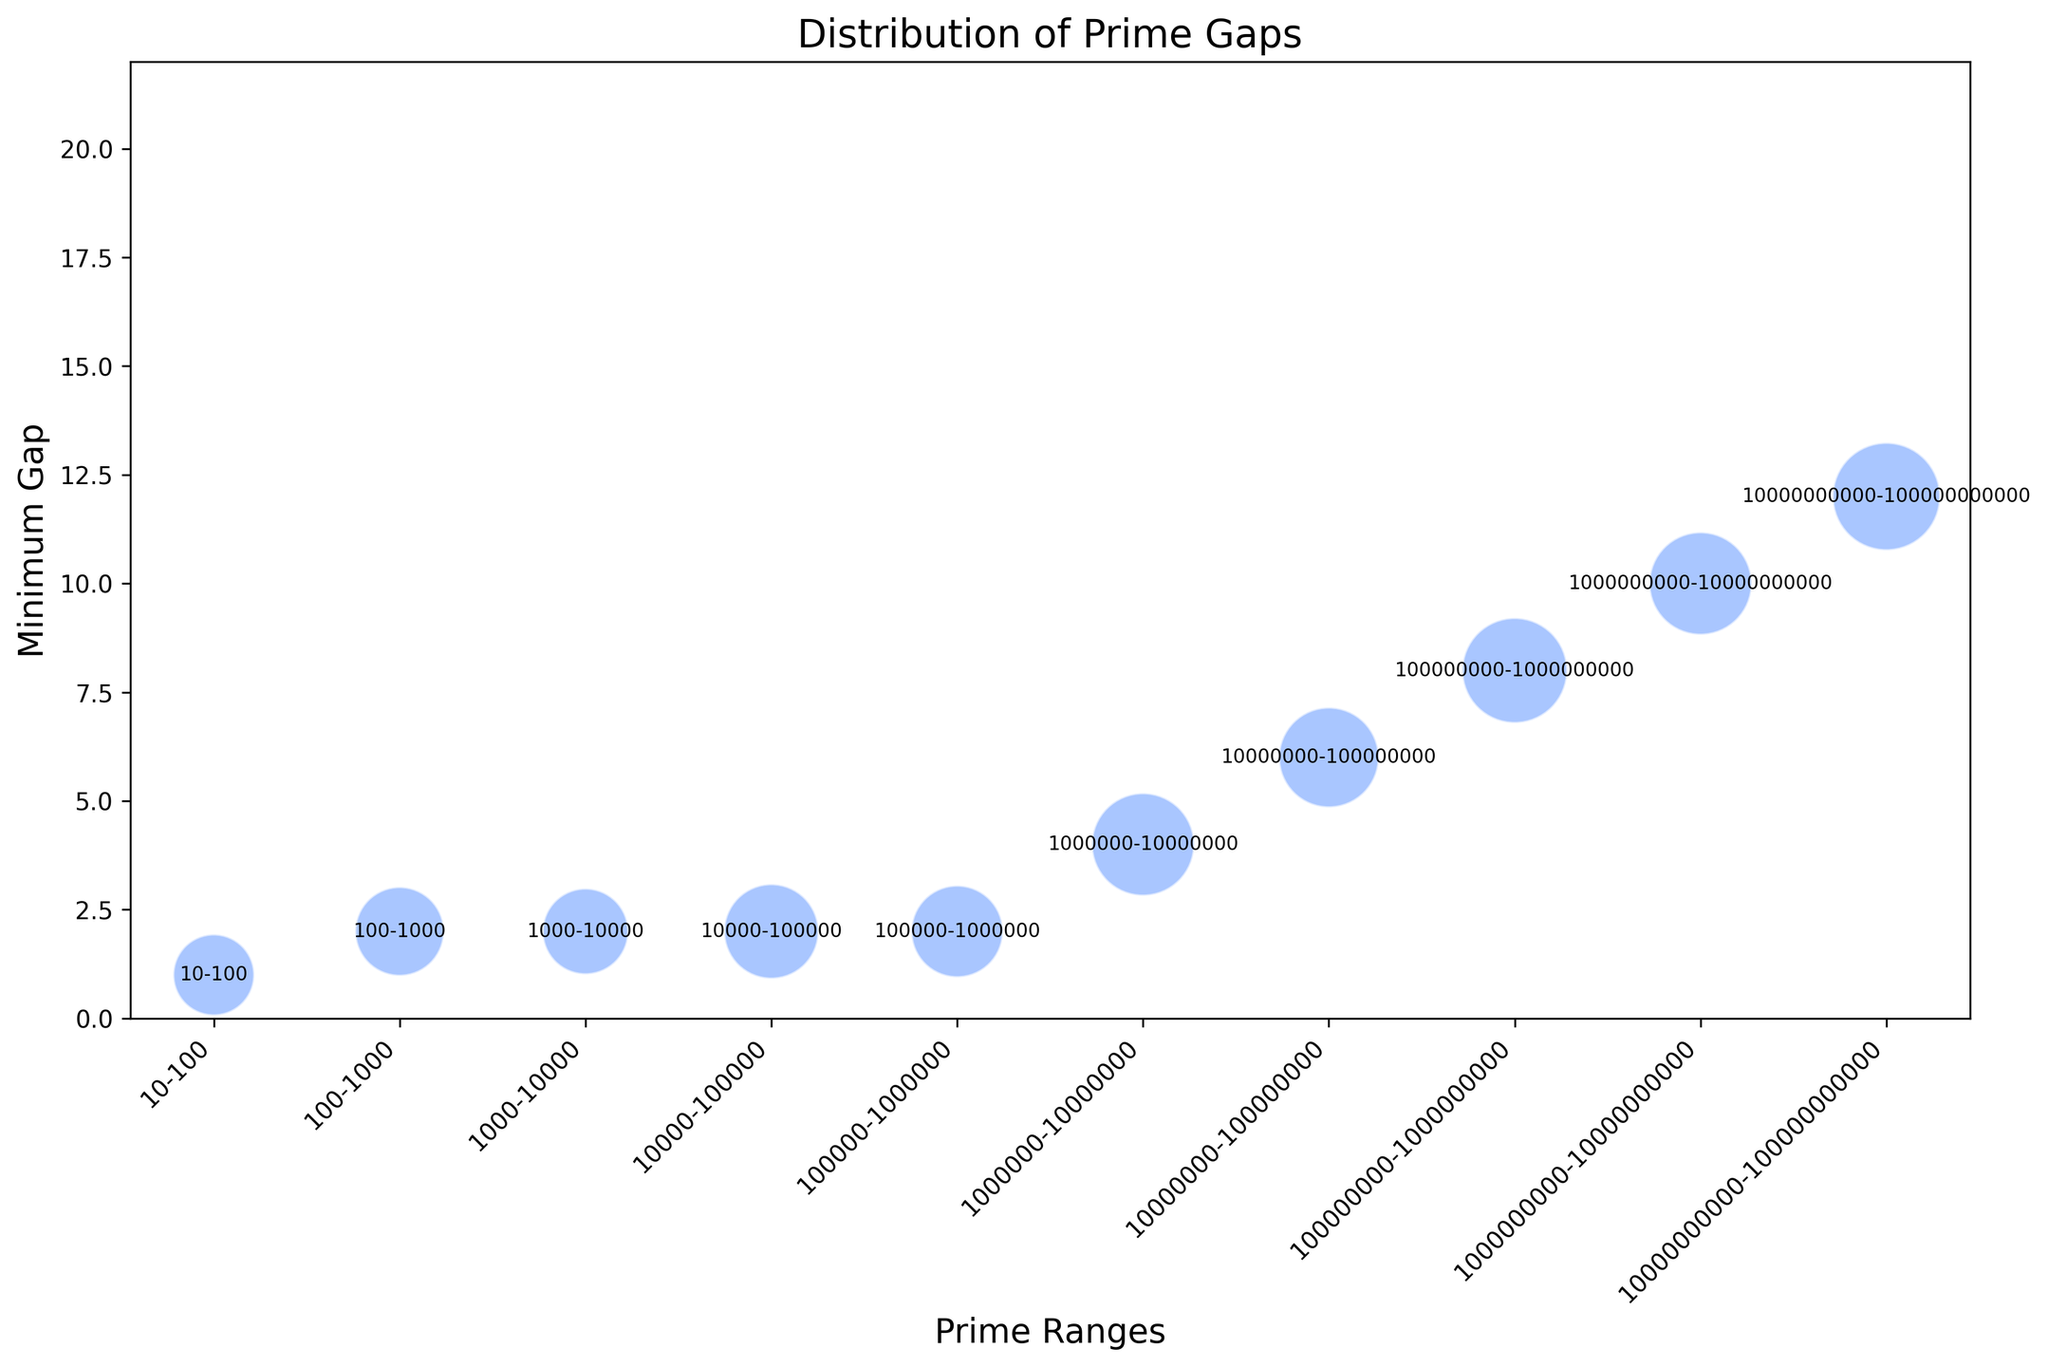How does the minimum prime gap trend change as the prime ranges increase? Starting from the range 10-100, the minimum prime gap initially increases with the prime ranges. It goes from 1 for 10-100 to 12 in the range 10000000000-100000000000, showing a general upward trend as the prime ranges increase.
Answer: The minimum prime gap generally increases Which prime range has the largest bubble size, indicating the highest count of prime gaps? The size of the bubbles is proportional to the count of prime gaps. The largest bubble size appears in the range 10000000000-100000000000. This indicates that it has the highest count of prime gaps, which is 44.
Answer: 10000000000-100000000000 Is there an instance where the minimum gap is greater than the maximum gap of a smaller range in prime ranges? If so, provide an example. Yes, for the range 1000000000-10000000000, the minimum gap is 10, which is larger than the maximum gaps for ranges 10-100, 100-1000, 1000-10000, and 10000-100000. For example, it is greater than the maximum gap 10 for the range 10-100.
Answer: Yes, 1000000000-10000000000 and 10-100 What is the trend in the maximum prime gap as the prime ranges increase? The maximum prime gap shows an increasing trend with the prime ranges, starting from 10 in the range 10-100 and going up to 250 in the range 10000000000-100000000000, indicating larger gaps between primes in higher ranges.
Answer: Increasing How do the prime ranges compare in terms of the variation between their minimum and maximum gaps? To find the variation, subtract the minimum gap from the maximum gap for each prime range:
10-100: 10 - 1 = 9
100-1000: 20 - 2 = 18
1000-10000: 30 - 2 = 28
10000-100000: 50 - 2 = 48
100000-1000000: 100 - 2 = 98
1000000-10000000: 130 - 4 = 126
10000000-100000000: 150 - 6 = 144
100000000-1000000000: 180 - 8 = 172
1000000000-10000000000: 210 - 10 = 200
10000000000-100000000000: 250 - 12 = 238
The variation between minimum and maximum gaps increases as the prime ranges get larger.
Answer: Increasing variation Which prime range has the smallest minimum gap? The smallest minimum gap, 1, is observed in the prime range 10-100.
Answer: 10-100 When you look at the prime range with the second-highest count of prime gaps, what are its minimum and maximum gaps? The prime range with the second-highest count of prime gaps is 100000000-1000000000, with a count of 42. Its minimum and maximum gaps are 8 and 180, respectively.
Answer: 8 and 180 Which prime range shows the highest variation between minimum and maximum gaps? The highest variation between minimum and maximum gaps, 238, is observed in the range 10000000000-100000000000.
Answer: 10000000000-100000000000 